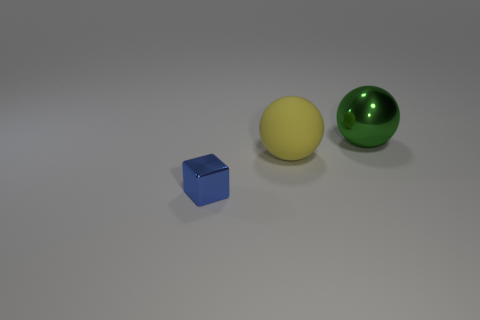Subtract all green balls. How many balls are left? 1 Add 1 green metal spheres. How many objects exist? 4 Subtract 2 balls. How many balls are left? 0 Subtract 1 blue cubes. How many objects are left? 2 Subtract all spheres. How many objects are left? 1 Subtract all gray cubes. Subtract all brown spheres. How many cubes are left? 1 Subtract all green metal balls. Subtract all metal blocks. How many objects are left? 1 Add 1 blue metallic objects. How many blue metallic objects are left? 2 Add 3 shiny spheres. How many shiny spheres exist? 4 